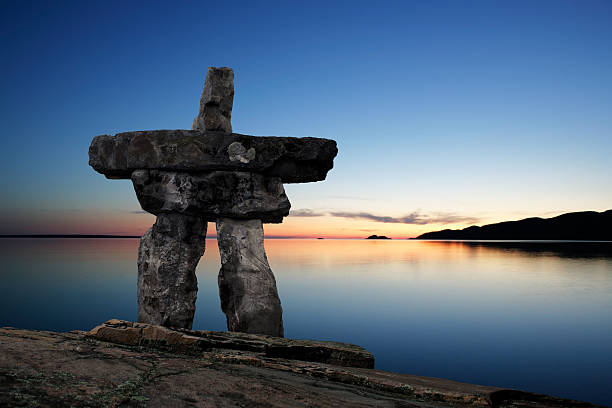Imagine the story behind why this Inukshuk was built here. In the heart of the Arctic, where the stark beauty of the land meets the endless sky, an Inuit elder named Anori decided to build an Inukshuk. Guided by ancestral wisdom, he sought to mark a special place where generations before him had gathered for the annual caribou migration. As he carefully stacked the stones, he infused each piece with not just physical balance but also spiritual significance. The structure became a silent sentinel, watching over the sacred hunting ground and reminding future generations of the harmony between nature and their way of life. The Inukshuk stood the test of time, enduring countless sunsets and sunrises, an eternal guardian of the stories, wisdom, and spirits of the past. Describe a typical day at the location of this image, from sunrise to sunset. At the break of dawn, the sky starts to lighten, painting soft gradients of purple and pink over the tranquil waters. Birds awaken in chorus, their melodies carried by a gentle breeze. As the sun rises, casting golden hues on the rocky shoreline, small waves lap rhythmically against the stones. The Inukshuk stands watch as a constant fixture, its silhouette etched gracefully against the morning glow. By midday, the warmth of the sun envelops the landscape, and the air is filled with the subtle sounds of nature—rustling leaves, distant calls of wildlife, and the occasional splash of a fish breaking the surface. As afternoon transitions to evening, the sky once again becomes a canvas of colors, deep blues melting into vibrant reds and oranges. The stillness of dusk descends, reflecting on the mirrored waters. Finally, as the sun sets, the world is bathed in serenity, and the Inukshuk silently observes another day's peaceful conclusion, waiting for the dawn of a new day. 